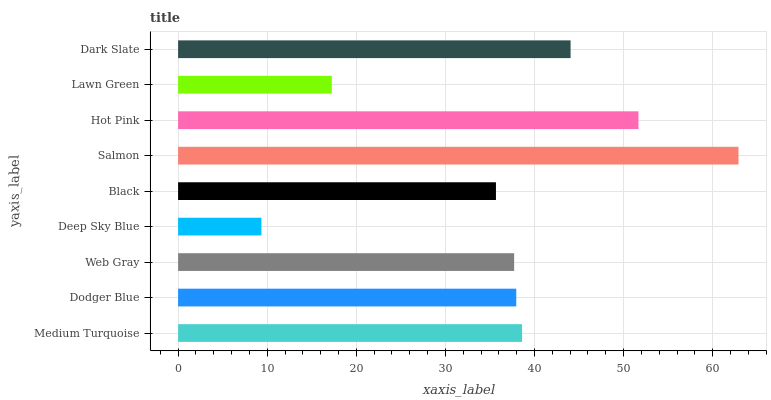Is Deep Sky Blue the minimum?
Answer yes or no. Yes. Is Salmon the maximum?
Answer yes or no. Yes. Is Dodger Blue the minimum?
Answer yes or no. No. Is Dodger Blue the maximum?
Answer yes or no. No. Is Medium Turquoise greater than Dodger Blue?
Answer yes or no. Yes. Is Dodger Blue less than Medium Turquoise?
Answer yes or no. Yes. Is Dodger Blue greater than Medium Turquoise?
Answer yes or no. No. Is Medium Turquoise less than Dodger Blue?
Answer yes or no. No. Is Dodger Blue the high median?
Answer yes or no. Yes. Is Dodger Blue the low median?
Answer yes or no. Yes. Is Hot Pink the high median?
Answer yes or no. No. Is Salmon the low median?
Answer yes or no. No. 